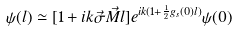<formula> <loc_0><loc_0><loc_500><loc_500>\psi ( l ) \simeq [ 1 + i k \vec { \sigma } \vec { M } l ] e ^ { i k ( 1 + \frac { 1 } { 2 } g _ { s } ( 0 ) l ) } \psi ( 0 )</formula> 